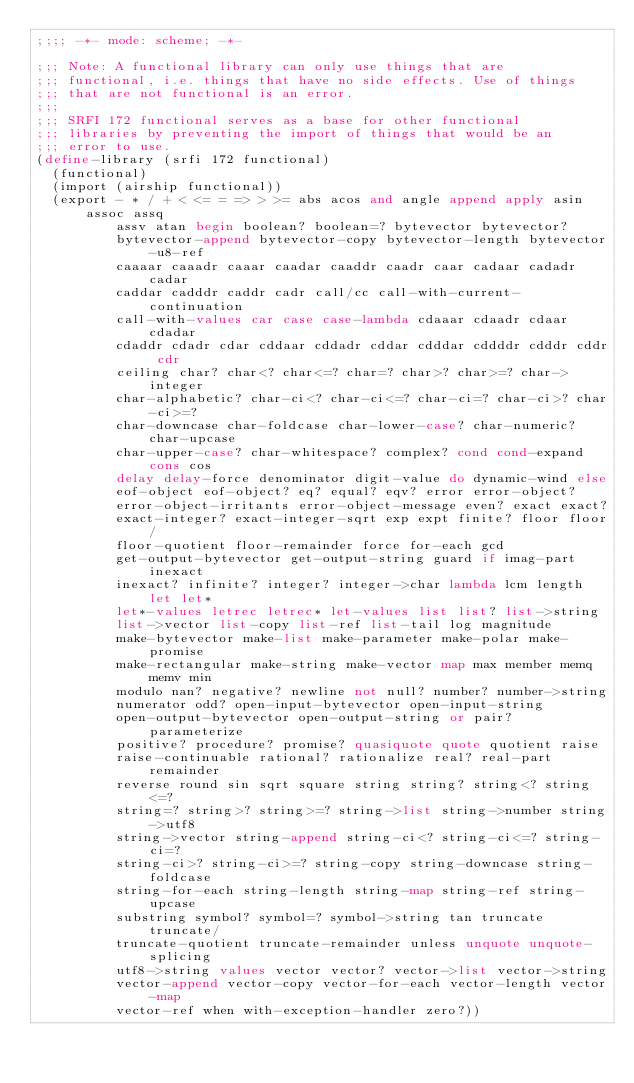<code> <loc_0><loc_0><loc_500><loc_500><_Scheme_>;;;; -*- mode: scheme; -*-

;;; Note: A functional library can only use things that are
;;; functional, i.e. things that have no side effects. Use of things
;;; that are not functional is an error.
;;;
;;; SRFI 172 functional serves as a base for other functional
;;; libraries by preventing the import of things that would be an
;;; error to use.
(define-library (srfi 172 functional)
  (functional)
  (import (airship functional))
  (export - * / + < <= = => > >= abs acos and angle append apply asin assoc assq
          assv atan begin boolean? boolean=? bytevector bytevector?
          bytevector-append bytevector-copy bytevector-length bytevector-u8-ref
          caaaar caaadr caaar caadar caaddr caadr caar cadaar cadadr cadar
          caddar cadddr caddr cadr call/cc call-with-current-continuation
          call-with-values car case case-lambda cdaaar cdaadr cdaar cdadar
          cdaddr cdadr cdar cddaar cddadr cddar cdddar cddddr cdddr cddr cdr
          ceiling char? char<? char<=? char=? char>? char>=? char->integer
          char-alphabetic? char-ci<? char-ci<=? char-ci=? char-ci>? char-ci>=?
          char-downcase char-foldcase char-lower-case? char-numeric? char-upcase
          char-upper-case? char-whitespace? complex? cond cond-expand cons cos
          delay delay-force denominator digit-value do dynamic-wind else
          eof-object eof-object? eq? equal? eqv? error error-object?
          error-object-irritants error-object-message even? exact exact?
          exact-integer? exact-integer-sqrt exp expt finite? floor floor/
          floor-quotient floor-remainder force for-each gcd
          get-output-bytevector get-output-string guard if imag-part inexact
          inexact? infinite? integer? integer->char lambda lcm length let let*
          let*-values letrec letrec* let-values list list? list->string
          list->vector list-copy list-ref list-tail log magnitude
          make-bytevector make-list make-parameter make-polar make-promise
          make-rectangular make-string make-vector map max member memq memv min
          modulo nan? negative? newline not null? number? number->string
          numerator odd? open-input-bytevector open-input-string
          open-output-bytevector open-output-string or pair? parameterize
          positive? procedure? promise? quasiquote quote quotient raise
          raise-continuable rational? rationalize real? real-part remainder
          reverse round sin sqrt square string string? string<? string<=?
          string=? string>? string>=? string->list string->number string->utf8
          string->vector string-append string-ci<? string-ci<=? string-ci=?
          string-ci>? string-ci>=? string-copy string-downcase string-foldcase
          string-for-each string-length string-map string-ref string-upcase
          substring symbol? symbol=? symbol->string tan truncate truncate/
          truncate-quotient truncate-remainder unless unquote unquote-splicing
          utf8->string values vector vector? vector->list vector->string
          vector-append vector-copy vector-for-each vector-length vector-map
          vector-ref when with-exception-handler zero?))
</code> 